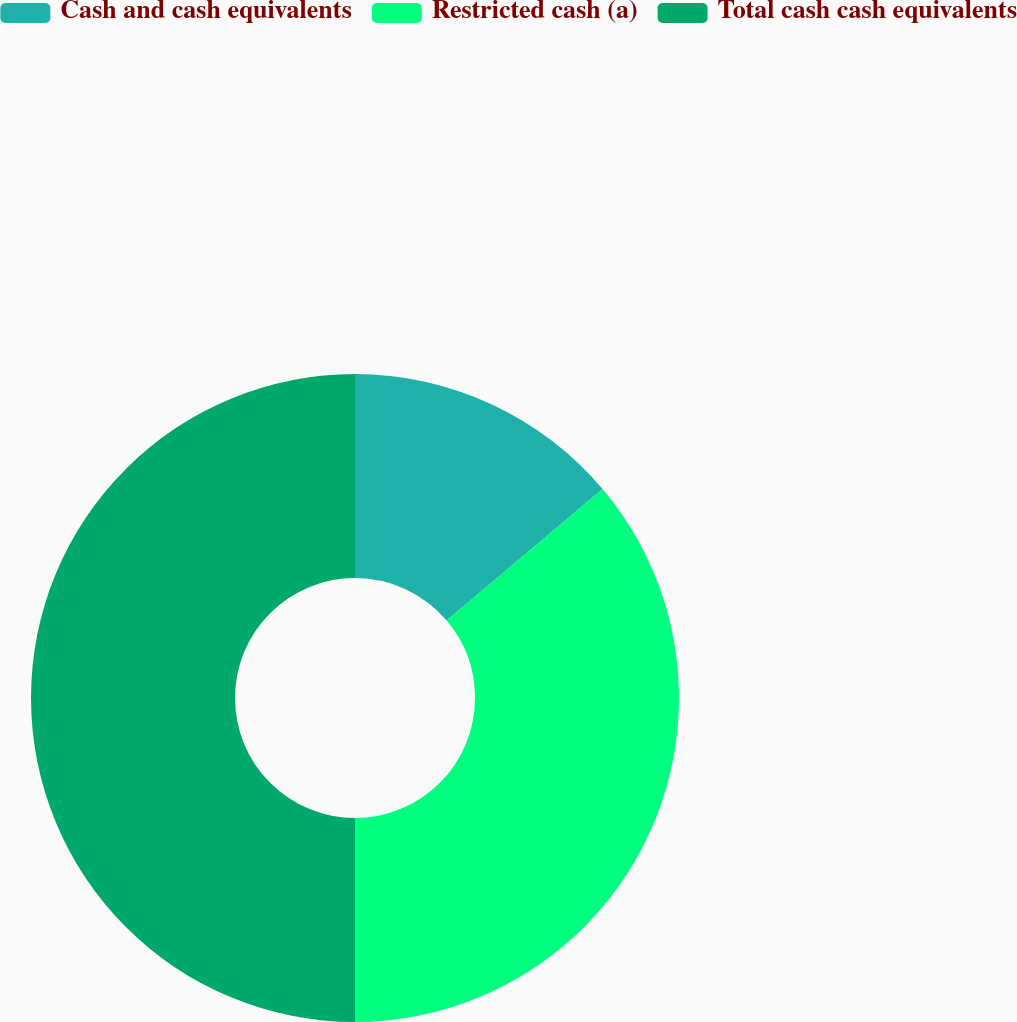Convert chart to OTSL. <chart><loc_0><loc_0><loc_500><loc_500><pie_chart><fcel>Cash and cash equivalents<fcel>Restricted cash (a)<fcel>Total cash cash equivalents<nl><fcel>13.84%<fcel>36.16%<fcel>50.0%<nl></chart> 